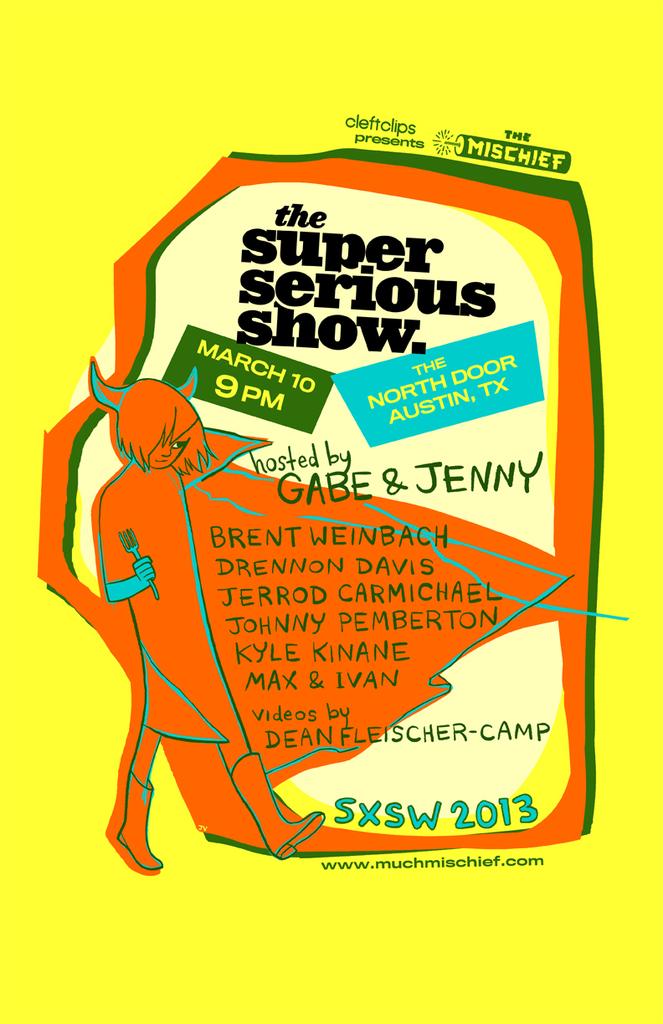Does this book look boring to everyone?
Give a very brief answer. No. When is this show?
Offer a terse response. March 10. 